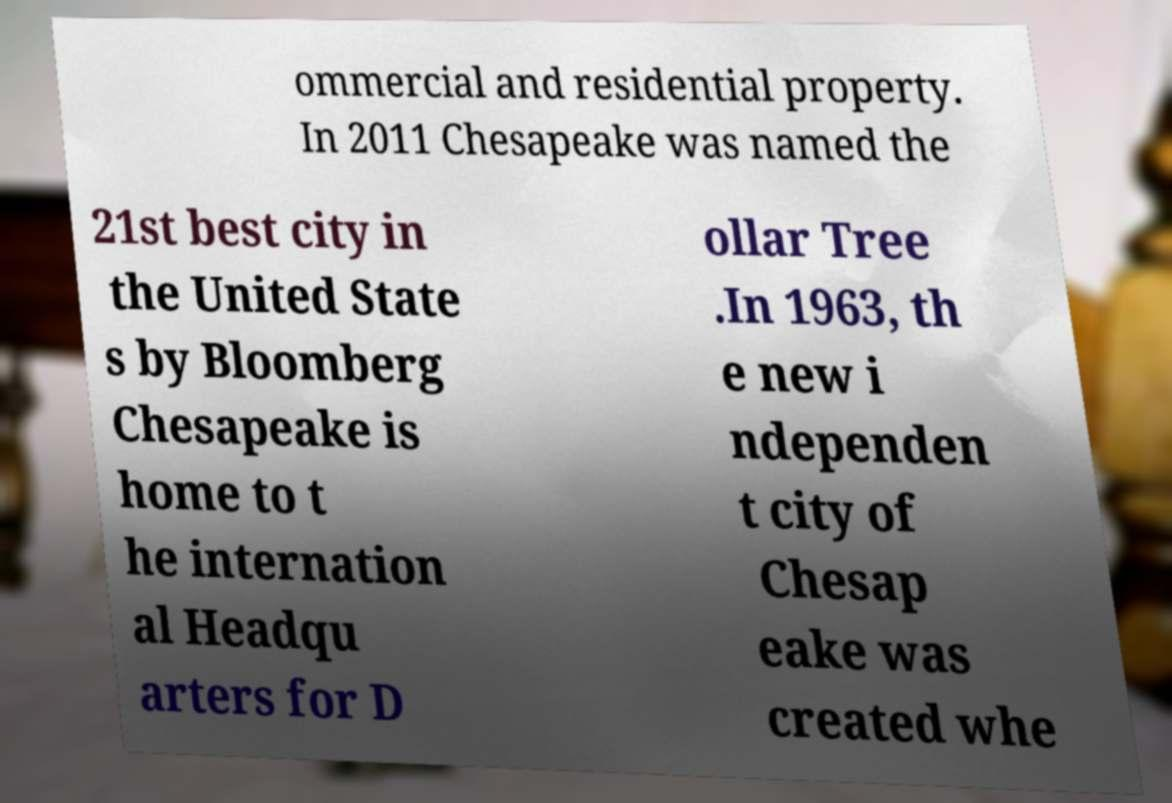Can you accurately transcribe the text from the provided image for me? ommercial and residential property. In 2011 Chesapeake was named the 21st best city in the United State s by Bloomberg Chesapeake is home to t he internation al Headqu arters for D ollar Tree .In 1963, th e new i ndependen t city of Chesap eake was created whe 